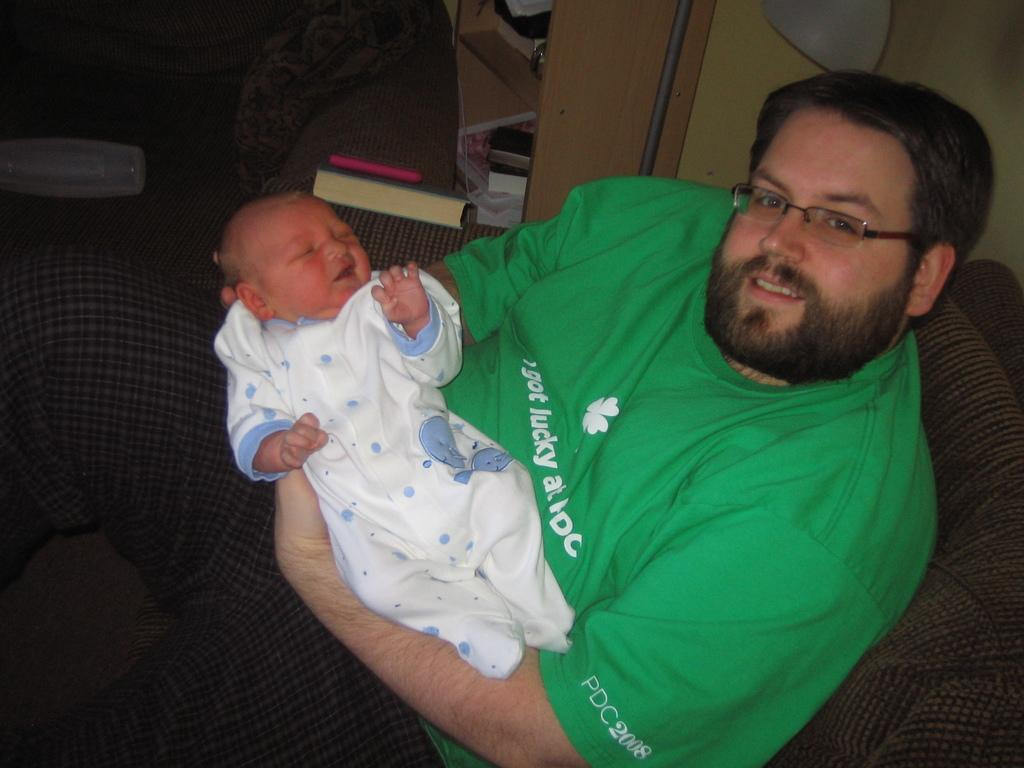<image>
Render a clear and concise summary of the photo. A young man is holding a small baby and wearing a green shirt which says "I got lucky at ...". 